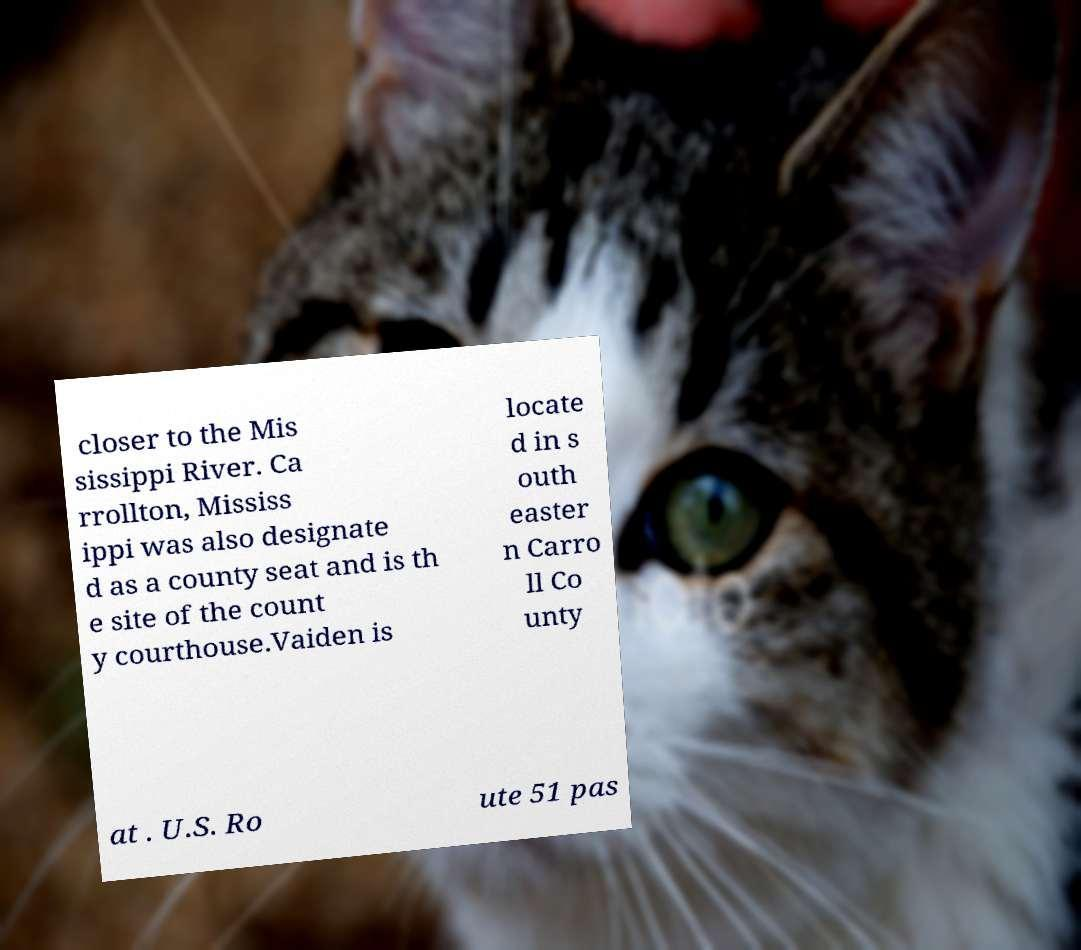Please identify and transcribe the text found in this image. closer to the Mis sissippi River. Ca rrollton, Mississ ippi was also designate d as a county seat and is th e site of the count y courthouse.Vaiden is locate d in s outh easter n Carro ll Co unty at . U.S. Ro ute 51 pas 